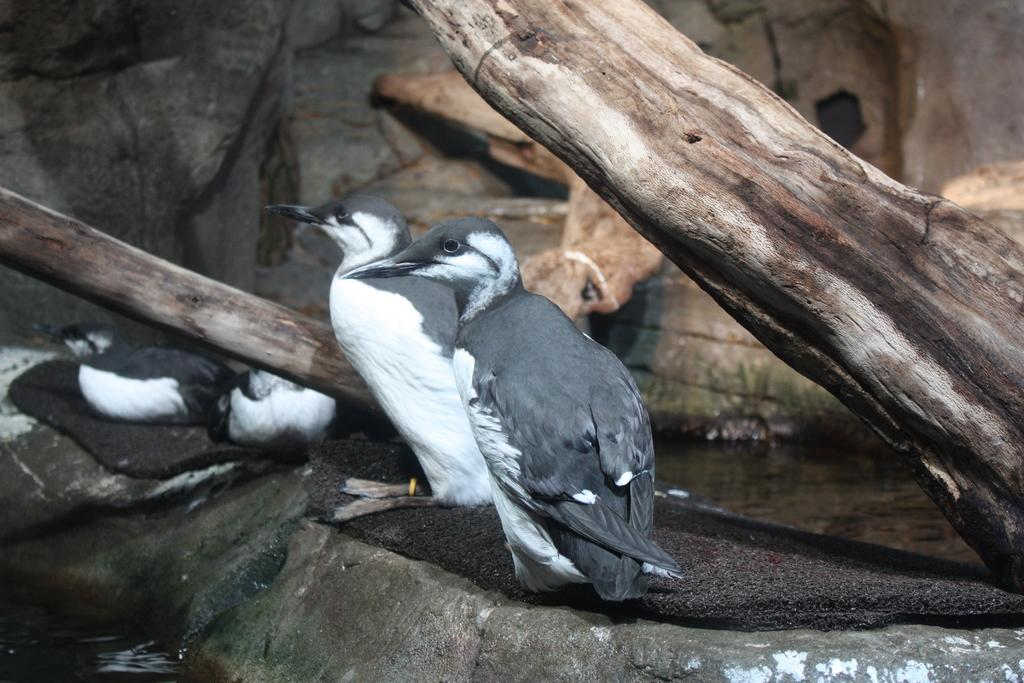What objects are in the foreground of the picture? There are wooden logs, mats, and birds that resemble ducks in the foreground of the picture. What can be seen on the left side of the picture? There is water on the left side of the picture. What structure is visible in the background of the picture? There is a well in the background of the picture. What type of toy can be seen floating in the water in the image? There is no toy present in the image; it features wooden logs, mats, birds, water, and a well. What ingredients are used to make the stew that is being cooked in the image? There is no stew being cooked in the image; it primarily focuses on the wooden logs, mats, birds, water, and well. 